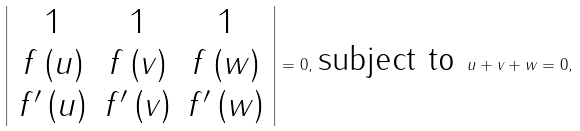Convert formula to latex. <formula><loc_0><loc_0><loc_500><loc_500>\left | \begin{array} { c c c } 1 & 1 & 1 \\ f \left ( u \right ) & f \left ( v \right ) & f \left ( w \right ) \\ f ^ { \prime } \left ( u \right ) & f ^ { \prime } \left ( v \right ) & f ^ { \prime } \left ( w \right ) \end{array} \right | = 0 , \, \text {subject to } u + v + w = 0 ,</formula> 